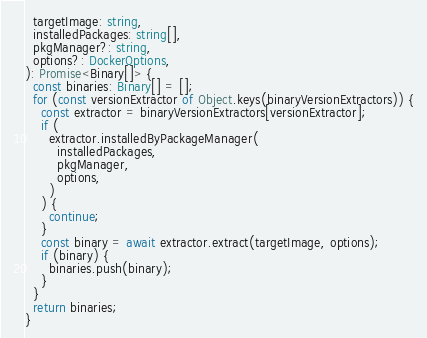Convert code to text. <code><loc_0><loc_0><loc_500><loc_500><_TypeScript_>  targetImage: string,
  installedPackages: string[],
  pkgManager?: string,
  options?: DockerOptions,
): Promise<Binary[]> {
  const binaries: Binary[] = [];
  for (const versionExtractor of Object.keys(binaryVersionExtractors)) {
    const extractor = binaryVersionExtractors[versionExtractor];
    if (
      extractor.installedByPackageManager(
        installedPackages,
        pkgManager,
        options,
      )
    ) {
      continue;
    }
    const binary = await extractor.extract(targetImage, options);
    if (binary) {
      binaries.push(binary);
    }
  }
  return binaries;
}
</code> 